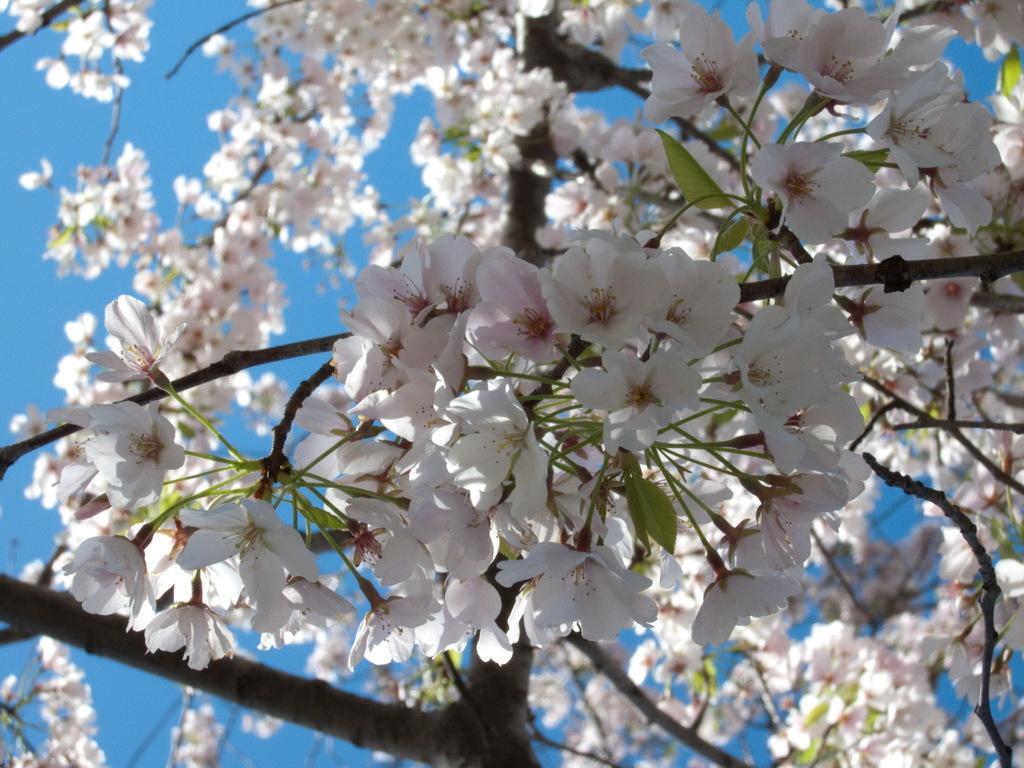Could you give a brief overview of what you see in this image? In the picture we can see a plant to it, we can see bunches of flowers which are white in color and behind it, we can see a sky which is blue in color. 